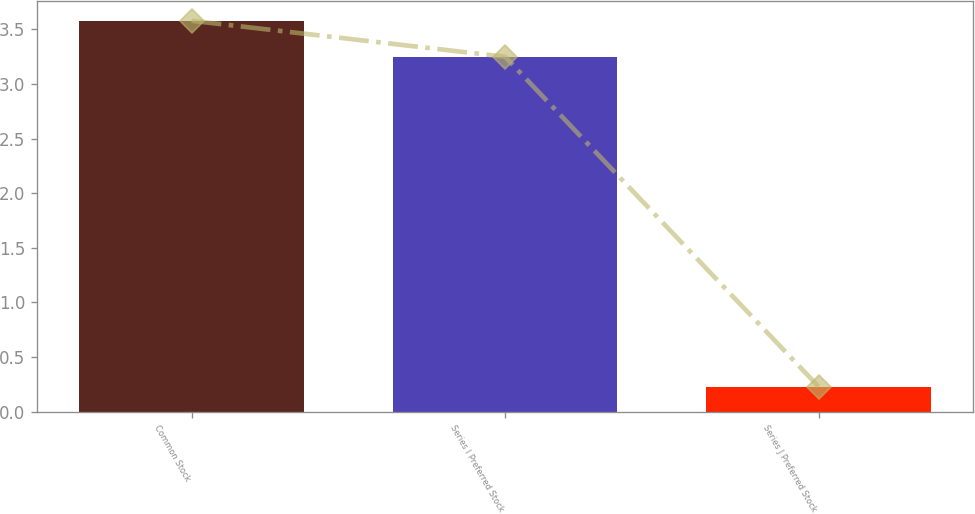<chart> <loc_0><loc_0><loc_500><loc_500><bar_chart><fcel>Common Stock<fcel>Series I Preferred Stock<fcel>Series J Preferred Stock<nl><fcel>3.58<fcel>3.25<fcel>0.23<nl></chart> 